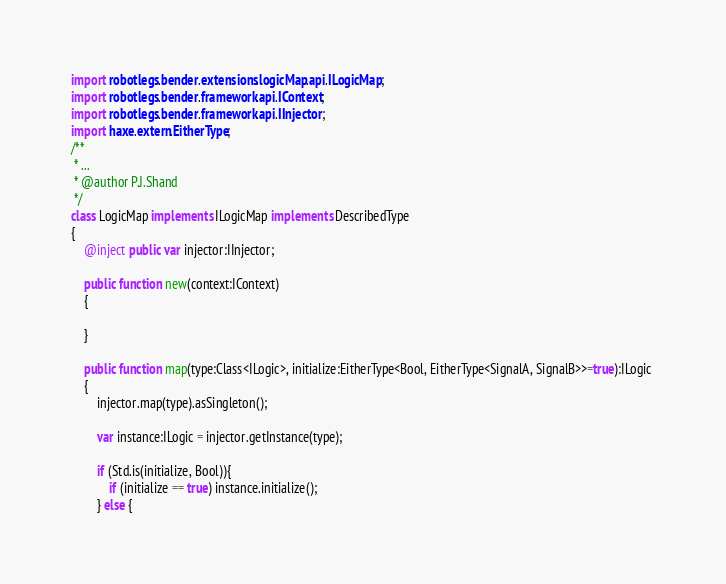Convert code to text. <code><loc_0><loc_0><loc_500><loc_500><_Haxe_>import robotlegs.bender.extensions.logicMap.api.ILogicMap;
import robotlegs.bender.framework.api.IContext;
import robotlegs.bender.framework.api.IInjector;
import haxe.extern.EitherType;
/**
 * ...
 * @author P.J.Shand
 */
class LogicMap implements ILogicMap implements DescribedType
{
	@inject public var injector:IInjector;
	
	public function new(context:IContext) 
	{
		
	}
	
	public function map(type:Class<ILogic>, initialize:EitherType<Bool, EitherType<SignalA, SignalB>>=true):ILogic 
	{
		injector.map(type).asSingleton();
		
		var instance:ILogic = injector.getInstance(type);
		
		if (Std.is(initialize, Bool)){
			if (initialize == true) instance.initialize();
		} else {</code> 